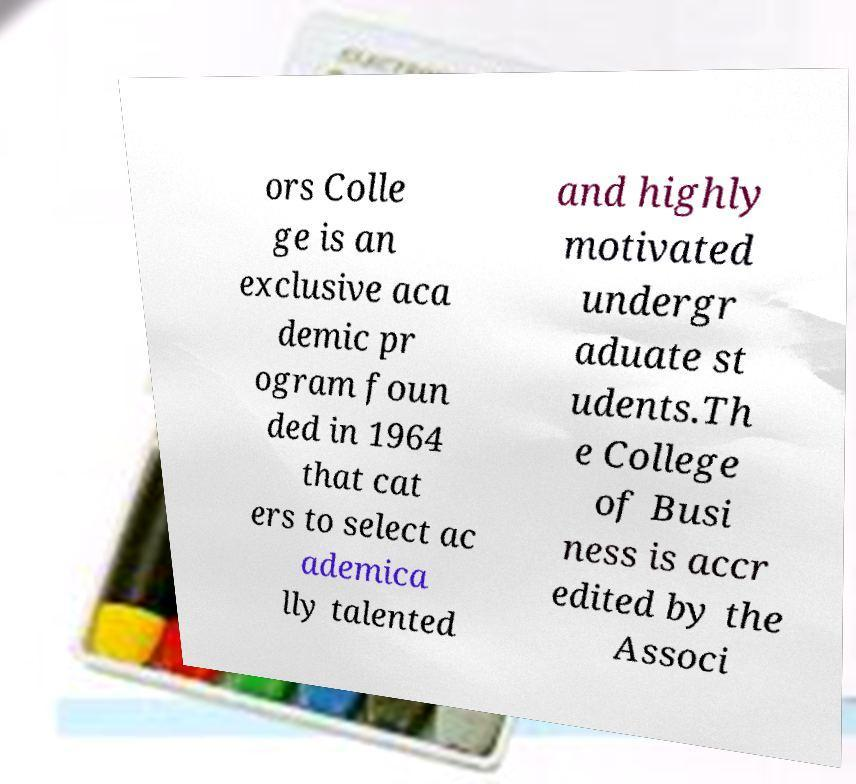I need the written content from this picture converted into text. Can you do that? ors Colle ge is an exclusive aca demic pr ogram foun ded in 1964 that cat ers to select ac ademica lly talented and highly motivated undergr aduate st udents.Th e College of Busi ness is accr edited by the Associ 